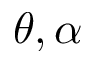Convert formula to latex. <formula><loc_0><loc_0><loc_500><loc_500>\theta , \alpha</formula> 